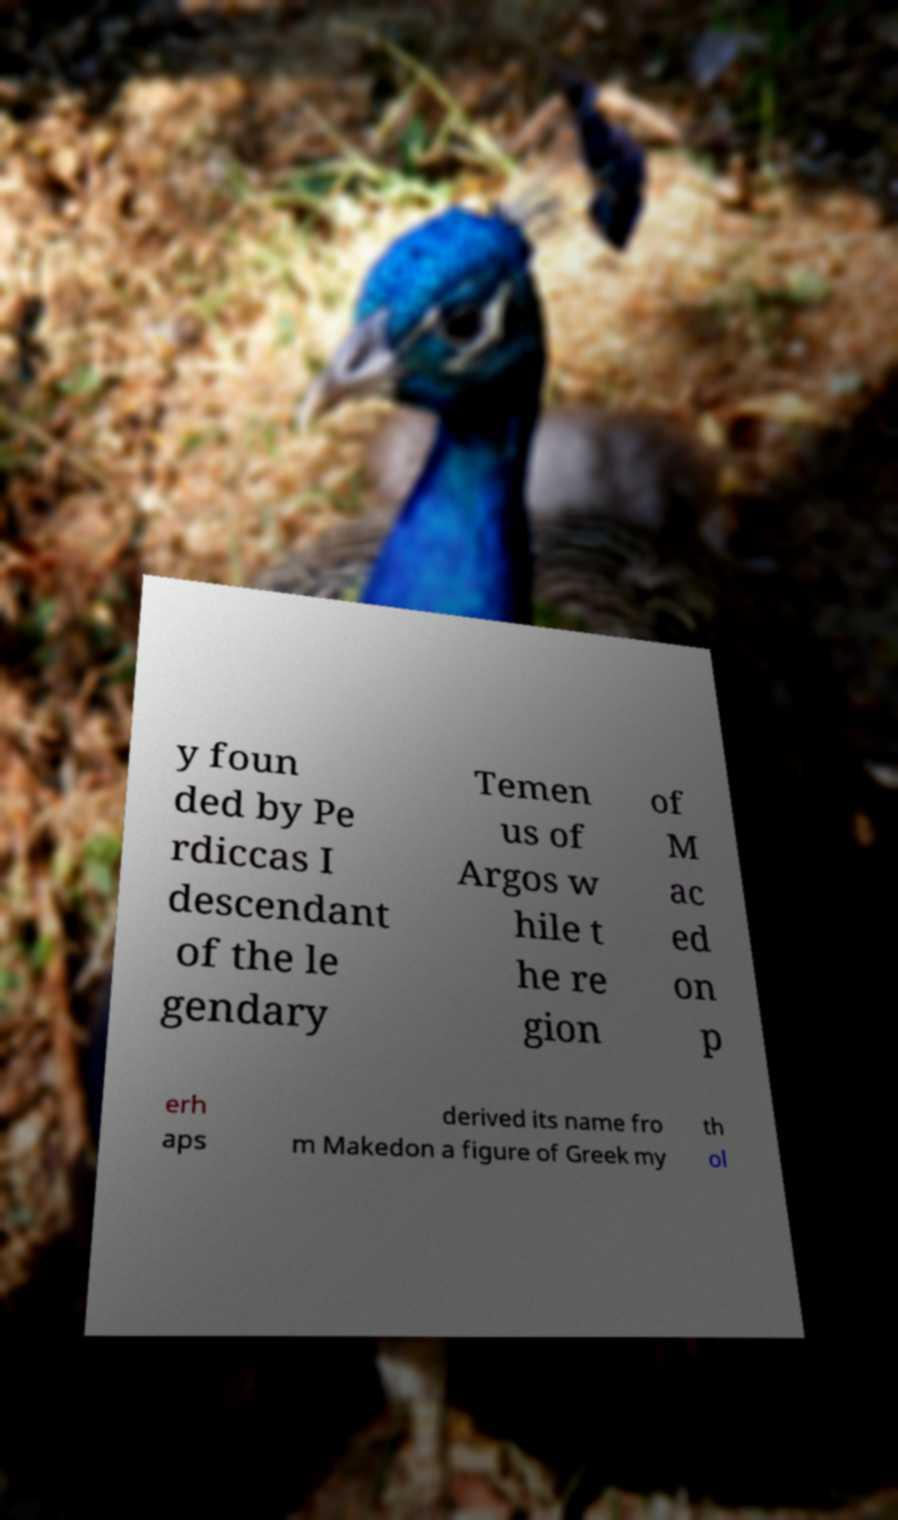For documentation purposes, I need the text within this image transcribed. Could you provide that? y foun ded by Pe rdiccas I descendant of the le gendary Temen us of Argos w hile t he re gion of M ac ed on p erh aps derived its name fro m Makedon a figure of Greek my th ol 